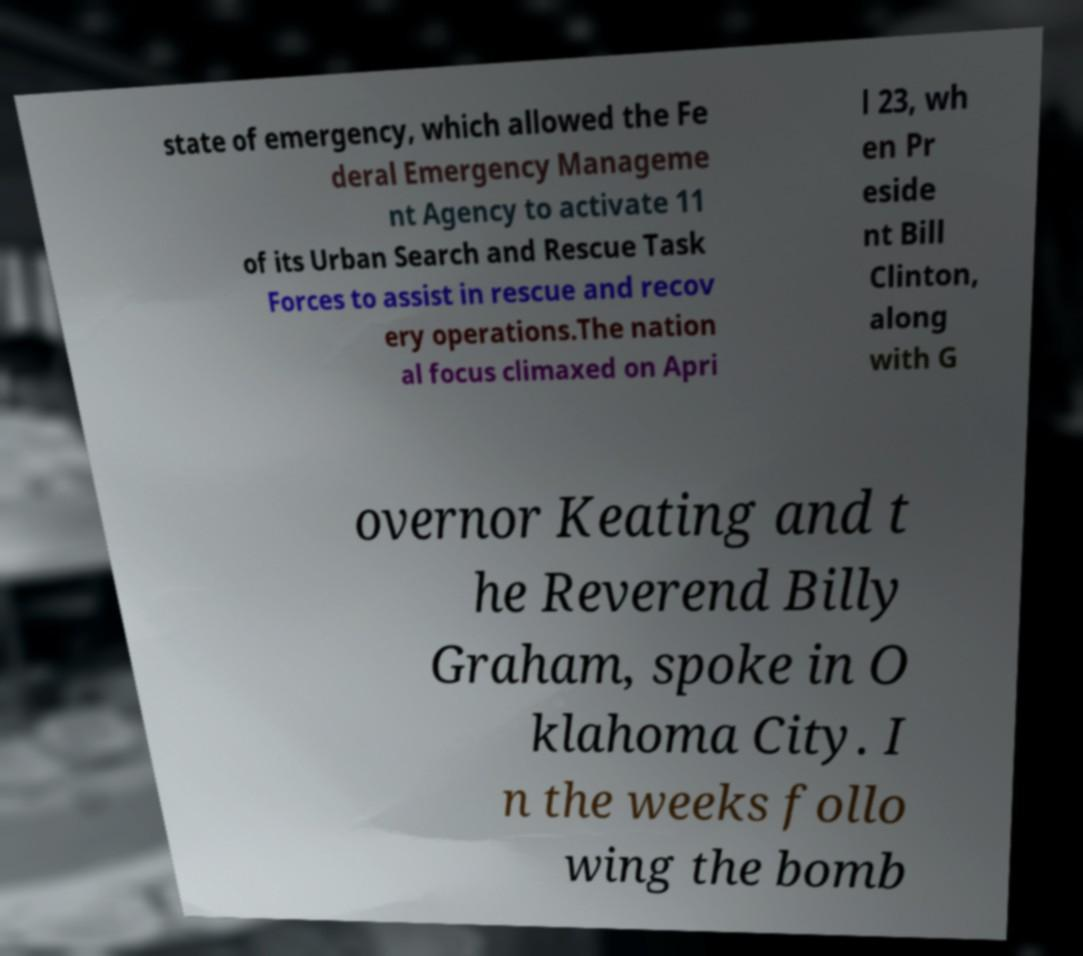I need the written content from this picture converted into text. Can you do that? state of emergency, which allowed the Fe deral Emergency Manageme nt Agency to activate 11 of its Urban Search and Rescue Task Forces to assist in rescue and recov ery operations.The nation al focus climaxed on Apri l 23, wh en Pr eside nt Bill Clinton, along with G overnor Keating and t he Reverend Billy Graham, spoke in O klahoma City. I n the weeks follo wing the bomb 